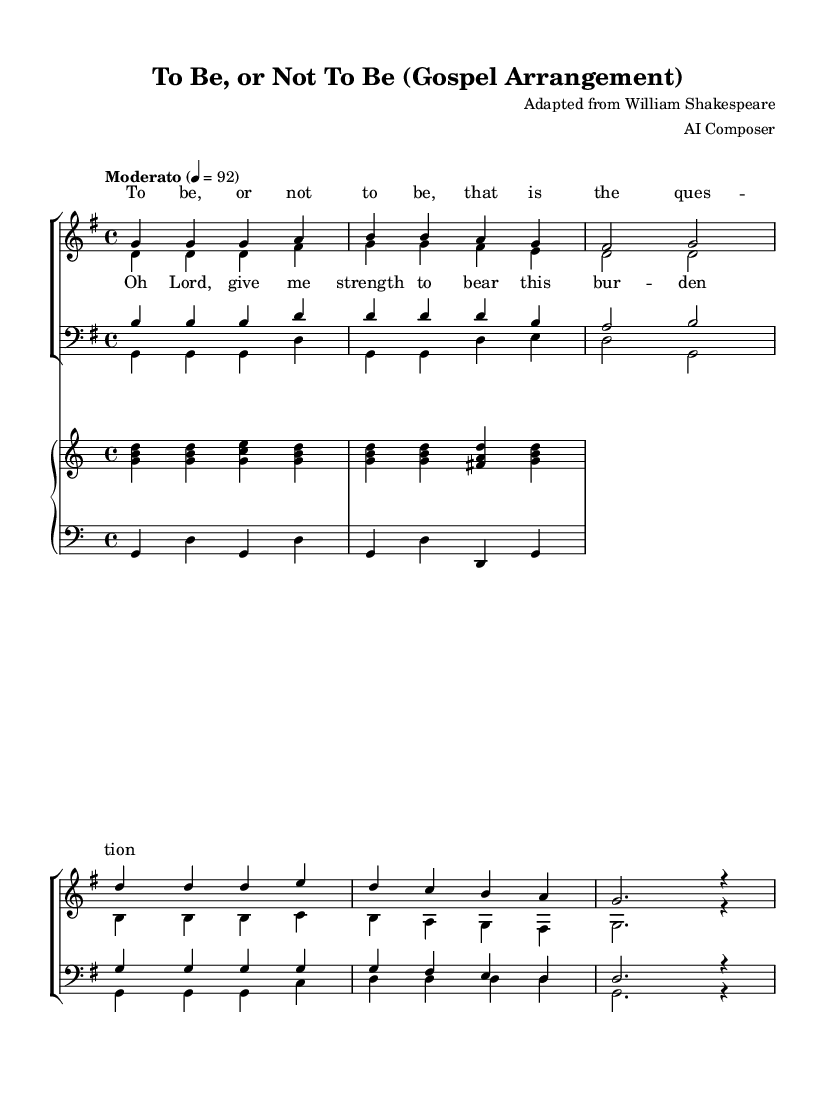What is the key signature of this music? The key signature is indicated at the beginning of the score and shows a single sharp (F#), which means it is in G major.
Answer: G major What is the time signature of this arrangement? The time signature appears at the beginning and is notated as 4 over 4, indicating four beats per measure.
Answer: 4/4 What is the tempo marking for this piece? The tempo marking is shared at the beginning of the score, indicating a moderato pace set to 92 beats per minute.
Answer: Moderato 92 How many voices are present in the choir arrangement? By analyzing the score, there are four distinct voice parts: sopranos, altos, tenors, and basses, totaling four voices.
Answer: Four What lyrical theme is explored in the chorus? The chorus words express a plea for strength, indicated in the lyrics "Oh Lord, give me strength to bear this burden," which reflects a spiritual theme.
Answer: Strength How does the soprano verse start musically? The soprano verse starts with three repeated notes of G followed by ascending notes A and B, confirming the arrangement's melodic structure.
Answer: G G G A B Which musical instruments accompany the choir? The score includes a piano staff with a right hand playing chords and a left hand playing bass notes, indicating that the piano accompanies the choir.
Answer: Piano 